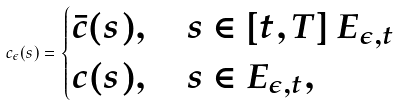<formula> <loc_0><loc_0><loc_500><loc_500>c _ { \epsilon } ( s ) = \begin{cases} \bar { c } ( s ) , \quad s \in [ t , T ] \ E _ { \epsilon , t } \\ c ( s ) , \quad s \in E _ { \epsilon , t } , \end{cases}</formula> 